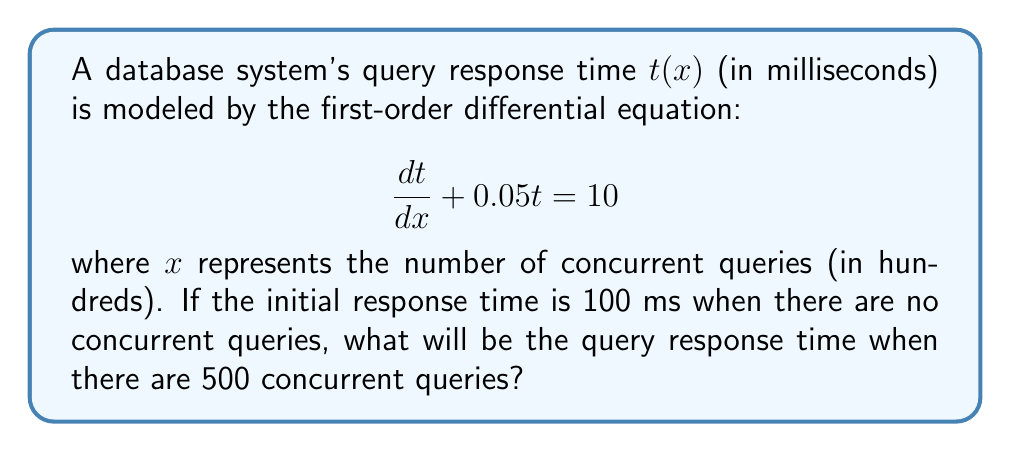Can you solve this math problem? To solve this problem, we'll follow these steps:

1) First, we recognize this as a first-order linear differential equation in the form:

   $$\frac{dy}{dx} + P(x)y = Q(x)$$

   where $P(x) = 0.05$ and $Q(x) = 10$.

2) The general solution for this type of equation is:

   $$y = e^{-\int P(x)dx} \left(\int Q(x)e^{\int P(x)dx}dx + C\right)$$

3) Let's solve the integrals:
   
   $\int P(x)dx = \int 0.05dx = 0.05x$
   
   $e^{\int P(x)dx} = e^{0.05x}$

4) Substituting into the general solution:

   $$t = e^{-0.05x} \left(\int 10e^{0.05x}dx + C\right)$$

5) Solving the integral:

   $$t = e^{-0.05x} \left(200e^{0.05x} + C\right)$$

6) Simplify:

   $$t = 200 + Ce^{-0.05x}$$

7) Use the initial condition to find C:
   When $x = 0$, $t = 100$
   
   $$100 = 200 + C$$
   $$C = -100$$

8) The particular solution is:

   $$t = 200 - 100e^{-0.05x}$$

9) To find the response time at 500 concurrent queries, we substitute $x = 5$ (remember, $x$ is in hundreds):

   $$t = 200 - 100e^{-0.05(5)}$$
   $$t = 200 - 100e^{-0.25}$$
   $$t \approx 177.88$$
Answer: The query response time when there are 500 concurrent queries will be approximately 177.88 milliseconds. 